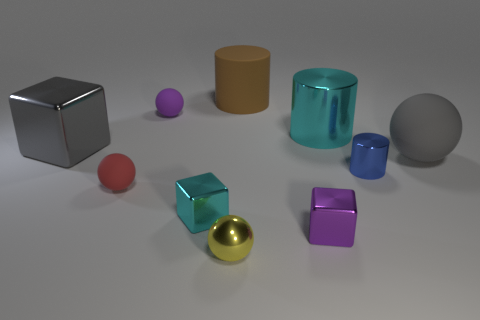Subtract 1 balls. How many balls are left? 3 Subtract all cylinders. How many objects are left? 7 Subtract 0 cyan spheres. How many objects are left? 10 Subtract all large brown rubber cylinders. Subtract all large brown matte objects. How many objects are left? 8 Add 8 gray rubber things. How many gray rubber things are left? 9 Add 2 green shiny cubes. How many green shiny cubes exist? 2 